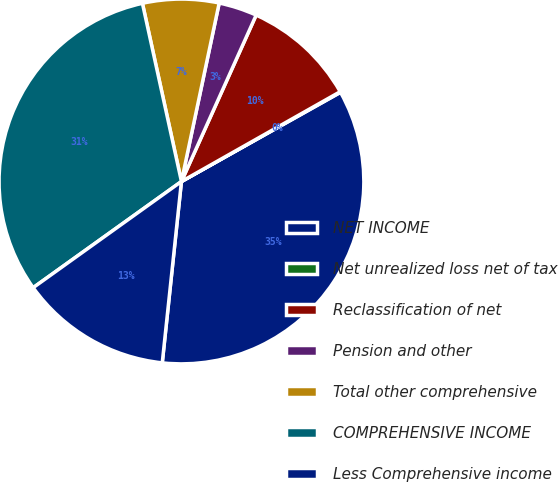Convert chart. <chart><loc_0><loc_0><loc_500><loc_500><pie_chart><fcel>NET INCOME<fcel>Net unrealized loss net of tax<fcel>Reclassification of net<fcel>Pension and other<fcel>Total other comprehensive<fcel>COMPREHENSIVE INCOME<fcel>Less Comprehensive income<nl><fcel>34.81%<fcel>0.06%<fcel>10.09%<fcel>3.4%<fcel>6.75%<fcel>31.46%<fcel>13.43%<nl></chart> 